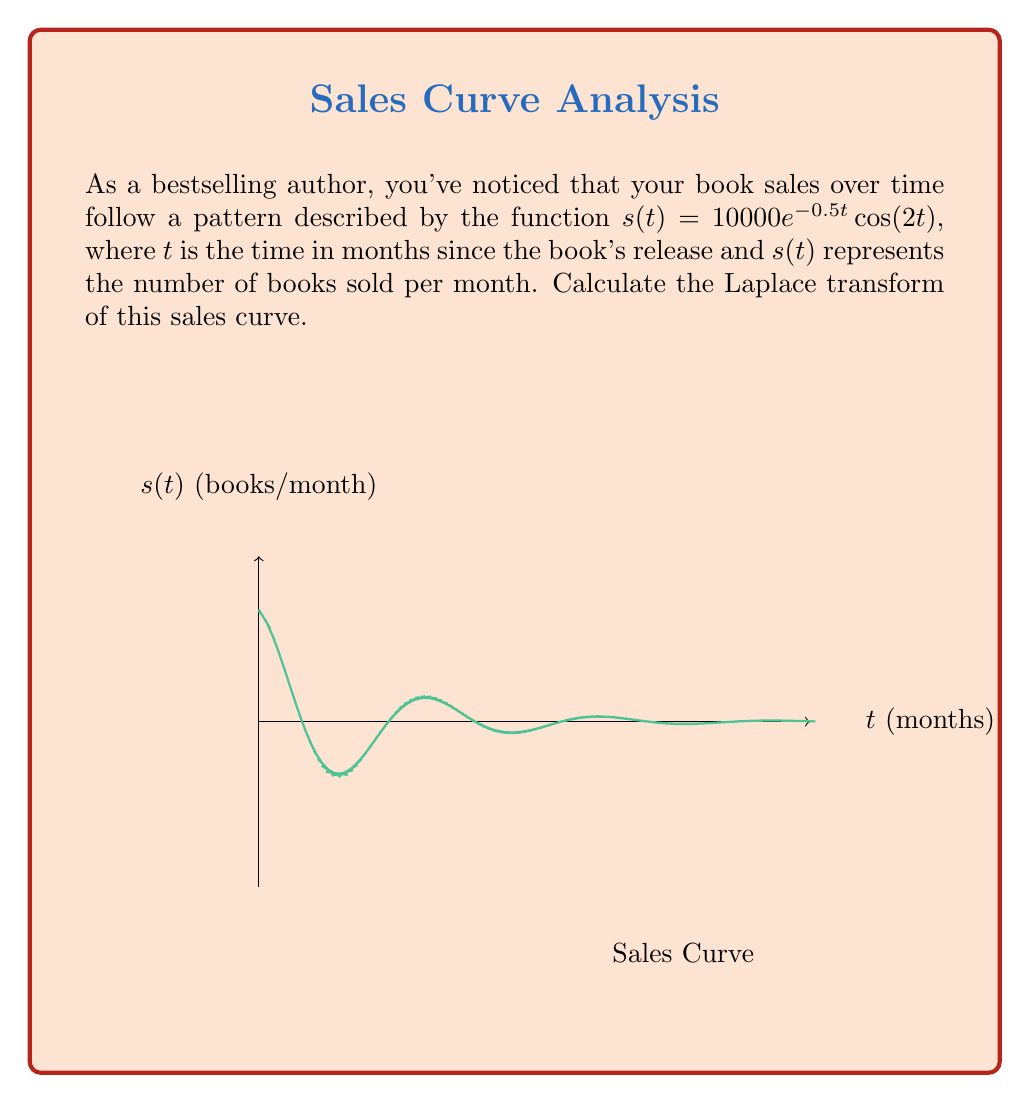Help me with this question. To find the Laplace transform of $s(t) = 10000e^{-0.5t}\cos(2t)$, we'll follow these steps:

1) The Laplace transform is defined as:
   $$\mathcal{L}\{f(t)\} = F(s) = \int_0^\infty e^{-st}f(t)dt$$

2) Substituting our function:
   $$\mathcal{L}\{s(t)\} = \int_0^\infty e^{-st}(10000e^{-0.5t}\cos(2t))dt$$

3) Factoring out the constant:
   $$\mathcal{L}\{s(t)\} = 10000\int_0^\infty e^{-(s+0.5)t}\cos(2t)dt$$

4) This integral matches the form of the Laplace transform of $\cos(at)$:
   $$\mathcal{L}\{\cos(at)\} = \frac{s}{s^2+a^2}$$

5) In our case, $a=2$ and we need to replace $s$ with $(s+0.5)$:
   $$\mathcal{L}\{s(t)\} = 10000\cdot\frac{s+0.5}{(s+0.5)^2+2^2}$$

6) Simplifying:
   $$\mathcal{L}\{s(t)\} = 10000\cdot\frac{s+0.5}{s^2+s+4.25}$$

This is the Laplace transform of the sales curve.
Answer: $$10000\cdot\frac{s+0.5}{s^2+s+4.25}$$ 